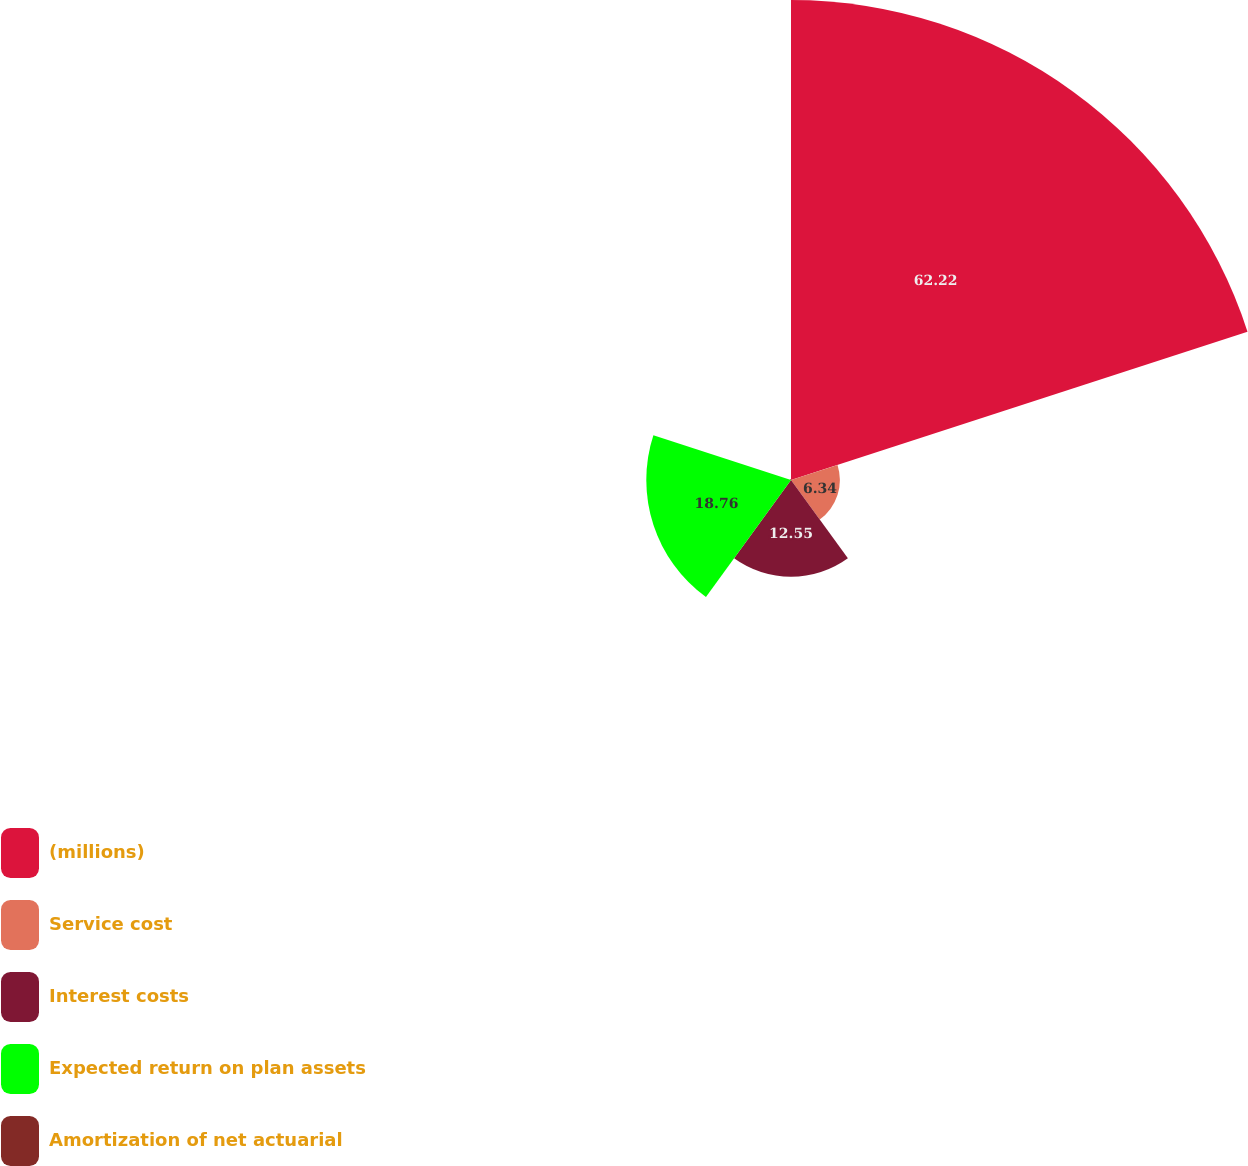<chart> <loc_0><loc_0><loc_500><loc_500><pie_chart><fcel>(millions)<fcel>Service cost<fcel>Interest costs<fcel>Expected return on plan assets<fcel>Amortization of net actuarial<nl><fcel>62.23%<fcel>6.34%<fcel>12.55%<fcel>18.76%<fcel>0.13%<nl></chart> 